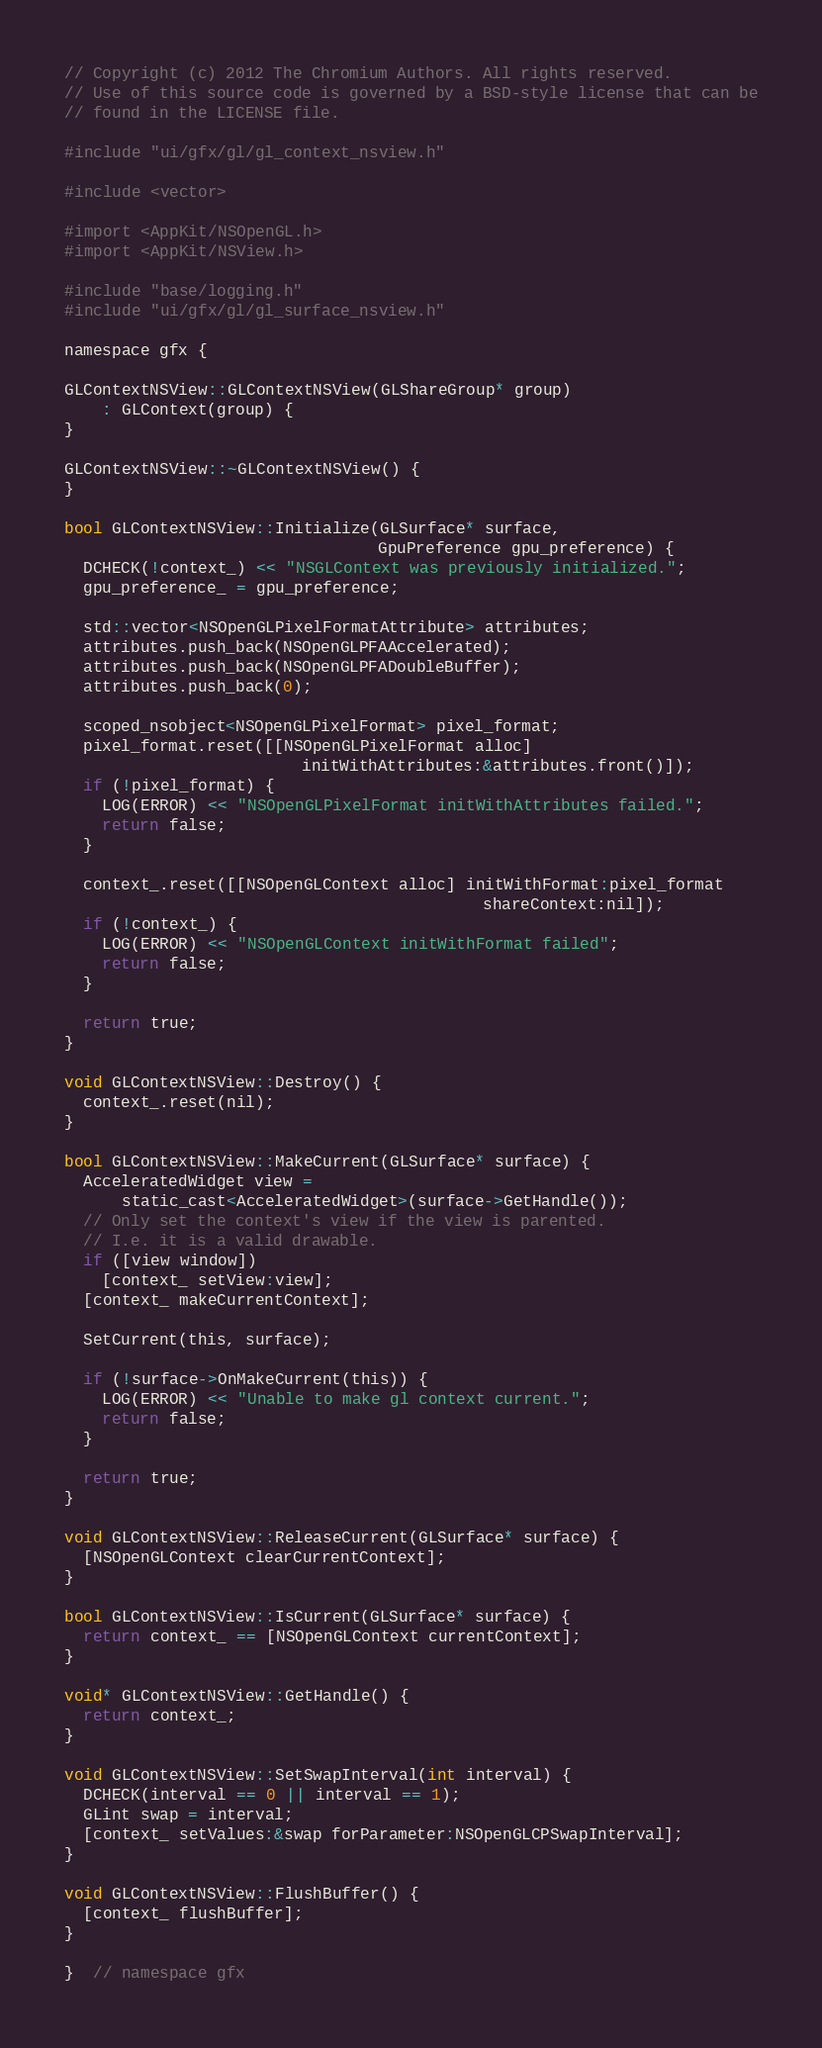Convert code to text. <code><loc_0><loc_0><loc_500><loc_500><_ObjectiveC_>// Copyright (c) 2012 The Chromium Authors. All rights reserved.
// Use of this source code is governed by a BSD-style license that can be
// found in the LICENSE file.

#include "ui/gfx/gl/gl_context_nsview.h"

#include <vector>

#import <AppKit/NSOpenGL.h>
#import <AppKit/NSView.h>

#include "base/logging.h"
#include "ui/gfx/gl/gl_surface_nsview.h"

namespace gfx {

GLContextNSView::GLContextNSView(GLShareGroup* group)
    : GLContext(group) {
}

GLContextNSView::~GLContextNSView() {
}

bool GLContextNSView::Initialize(GLSurface* surface,
                                 GpuPreference gpu_preference) {
  DCHECK(!context_) << "NSGLContext was previously initialized.";
  gpu_preference_ = gpu_preference;

  std::vector<NSOpenGLPixelFormatAttribute> attributes;
  attributes.push_back(NSOpenGLPFAAccelerated);
  attributes.push_back(NSOpenGLPFADoubleBuffer);
  attributes.push_back(0);

  scoped_nsobject<NSOpenGLPixelFormat> pixel_format;
  pixel_format.reset([[NSOpenGLPixelFormat alloc]
                         initWithAttributes:&attributes.front()]);
  if (!pixel_format) {
    LOG(ERROR) << "NSOpenGLPixelFormat initWithAttributes failed.";
    return false;
  }

  context_.reset([[NSOpenGLContext alloc] initWithFormat:pixel_format
                                            shareContext:nil]);
  if (!context_) {
    LOG(ERROR) << "NSOpenGLContext initWithFormat failed";
    return false;
  }

  return true;
}

void GLContextNSView::Destroy() {
  context_.reset(nil);
}

bool GLContextNSView::MakeCurrent(GLSurface* surface) {
  AcceleratedWidget view =
      static_cast<AcceleratedWidget>(surface->GetHandle());
  // Only set the context's view if the view is parented.
  // I.e. it is a valid drawable.
  if ([view window])
    [context_ setView:view];
  [context_ makeCurrentContext];

  SetCurrent(this, surface);

  if (!surface->OnMakeCurrent(this)) {
    LOG(ERROR) << "Unable to make gl context current.";
    return false;
  }

  return true;
}

void GLContextNSView::ReleaseCurrent(GLSurface* surface) {
  [NSOpenGLContext clearCurrentContext];
}

bool GLContextNSView::IsCurrent(GLSurface* surface) {
  return context_ == [NSOpenGLContext currentContext];
}

void* GLContextNSView::GetHandle() {
  return context_;
}

void GLContextNSView::SetSwapInterval(int interval) {
  DCHECK(interval == 0 || interval == 1);
  GLint swap = interval;
  [context_ setValues:&swap forParameter:NSOpenGLCPSwapInterval];
}

void GLContextNSView::FlushBuffer() {
  [context_ flushBuffer];
}

}  // namespace gfx
</code> 